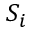Convert formula to latex. <formula><loc_0><loc_0><loc_500><loc_500>S _ { i }</formula> 